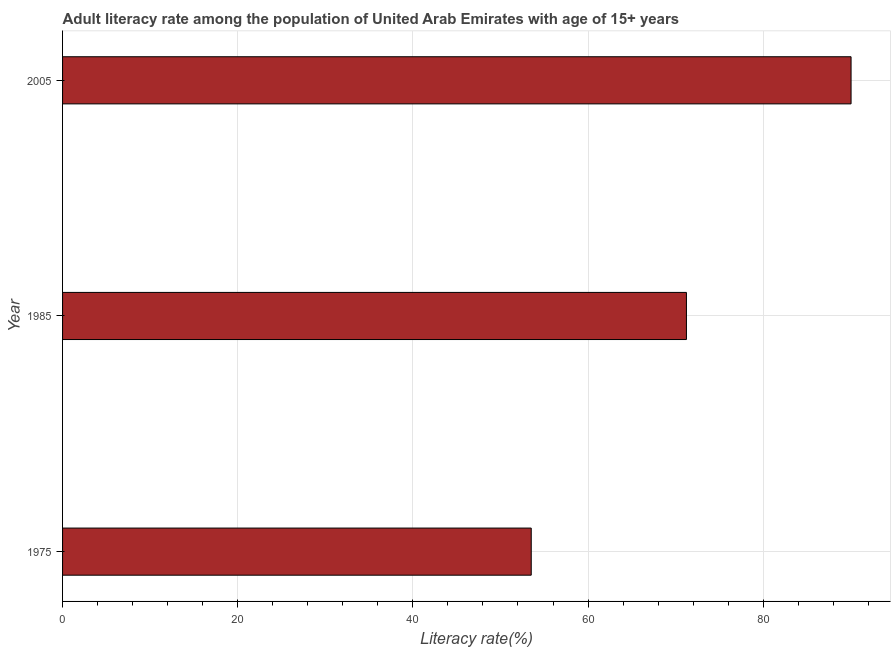What is the title of the graph?
Your response must be concise. Adult literacy rate among the population of United Arab Emirates with age of 15+ years. What is the label or title of the X-axis?
Give a very brief answer. Literacy rate(%). What is the label or title of the Y-axis?
Give a very brief answer. Year. What is the adult literacy rate in 1985?
Make the answer very short. 71.24. Across all years, what is the maximum adult literacy rate?
Your response must be concise. 90.03. Across all years, what is the minimum adult literacy rate?
Offer a terse response. 53.51. In which year was the adult literacy rate minimum?
Provide a short and direct response. 1975. What is the sum of the adult literacy rate?
Offer a very short reply. 214.78. What is the difference between the adult literacy rate in 1975 and 2005?
Offer a very short reply. -36.52. What is the average adult literacy rate per year?
Ensure brevity in your answer.  71.59. What is the median adult literacy rate?
Provide a short and direct response. 71.24. In how many years, is the adult literacy rate greater than 20 %?
Provide a short and direct response. 3. Do a majority of the years between 1985 and 2005 (inclusive) have adult literacy rate greater than 48 %?
Give a very brief answer. Yes. What is the ratio of the adult literacy rate in 1975 to that in 2005?
Your response must be concise. 0.59. Is the difference between the adult literacy rate in 1985 and 2005 greater than the difference between any two years?
Make the answer very short. No. What is the difference between the highest and the second highest adult literacy rate?
Ensure brevity in your answer.  18.8. What is the difference between the highest and the lowest adult literacy rate?
Give a very brief answer. 36.52. How many bars are there?
Provide a succinct answer. 3. What is the difference between two consecutive major ticks on the X-axis?
Make the answer very short. 20. What is the Literacy rate(%) of 1975?
Provide a succinct answer. 53.51. What is the Literacy rate(%) in 1985?
Your answer should be compact. 71.24. What is the Literacy rate(%) in 2005?
Ensure brevity in your answer.  90.03. What is the difference between the Literacy rate(%) in 1975 and 1985?
Give a very brief answer. -17.72. What is the difference between the Literacy rate(%) in 1975 and 2005?
Your answer should be compact. -36.52. What is the difference between the Literacy rate(%) in 1985 and 2005?
Your answer should be very brief. -18.8. What is the ratio of the Literacy rate(%) in 1975 to that in 1985?
Your answer should be very brief. 0.75. What is the ratio of the Literacy rate(%) in 1975 to that in 2005?
Make the answer very short. 0.59. What is the ratio of the Literacy rate(%) in 1985 to that in 2005?
Provide a short and direct response. 0.79. 